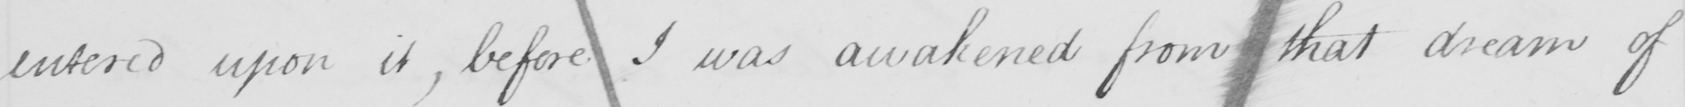What does this handwritten line say? entered upon it, before I was awakened from that dream of 